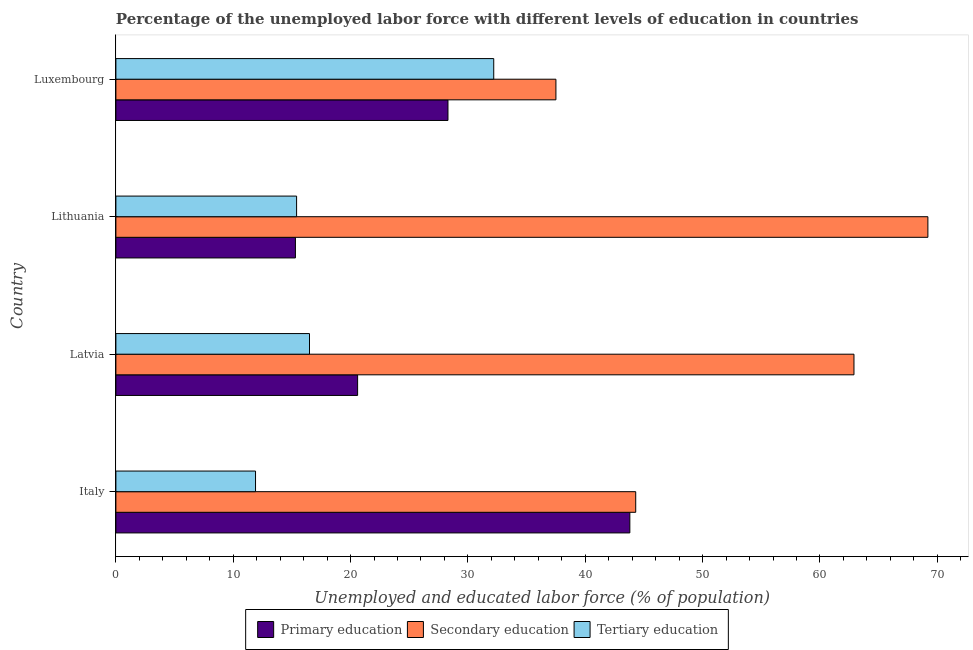How many different coloured bars are there?
Your answer should be very brief. 3. Are the number of bars on each tick of the Y-axis equal?
Your answer should be very brief. Yes. What is the label of the 2nd group of bars from the top?
Offer a very short reply. Lithuania. In how many cases, is the number of bars for a given country not equal to the number of legend labels?
Your answer should be compact. 0. What is the percentage of labor force who received primary education in Latvia?
Your answer should be very brief. 20.6. Across all countries, what is the maximum percentage of labor force who received primary education?
Your answer should be very brief. 43.8. Across all countries, what is the minimum percentage of labor force who received primary education?
Offer a very short reply. 15.3. In which country was the percentage of labor force who received tertiary education maximum?
Offer a very short reply. Luxembourg. What is the total percentage of labor force who received primary education in the graph?
Provide a succinct answer. 108. What is the difference between the percentage of labor force who received primary education in Luxembourg and the percentage of labor force who received tertiary education in Lithuania?
Provide a succinct answer. 12.9. What is the average percentage of labor force who received secondary education per country?
Your answer should be very brief. 53.48. What is the difference between the percentage of labor force who received secondary education and percentage of labor force who received tertiary education in Lithuania?
Provide a short and direct response. 53.8. What is the ratio of the percentage of labor force who received secondary education in Italy to that in Latvia?
Your response must be concise. 0.7. Is the percentage of labor force who received tertiary education in Italy less than that in Lithuania?
Your answer should be very brief. Yes. Is the difference between the percentage of labor force who received primary education in Italy and Luxembourg greater than the difference between the percentage of labor force who received secondary education in Italy and Luxembourg?
Provide a succinct answer. Yes. What is the difference between the highest and the lowest percentage of labor force who received primary education?
Make the answer very short. 28.5. What does the 2nd bar from the top in Latvia represents?
Offer a very short reply. Secondary education. What does the 1st bar from the bottom in Luxembourg represents?
Your answer should be compact. Primary education. How many bars are there?
Offer a very short reply. 12. Are all the bars in the graph horizontal?
Keep it short and to the point. Yes. How many countries are there in the graph?
Offer a very short reply. 4. Does the graph contain any zero values?
Your answer should be very brief. No. How are the legend labels stacked?
Provide a short and direct response. Horizontal. What is the title of the graph?
Provide a short and direct response. Percentage of the unemployed labor force with different levels of education in countries. What is the label or title of the X-axis?
Provide a short and direct response. Unemployed and educated labor force (% of population). What is the Unemployed and educated labor force (% of population) of Primary education in Italy?
Your answer should be compact. 43.8. What is the Unemployed and educated labor force (% of population) of Secondary education in Italy?
Keep it short and to the point. 44.3. What is the Unemployed and educated labor force (% of population) in Tertiary education in Italy?
Your answer should be very brief. 11.9. What is the Unemployed and educated labor force (% of population) in Primary education in Latvia?
Your response must be concise. 20.6. What is the Unemployed and educated labor force (% of population) in Secondary education in Latvia?
Your answer should be very brief. 62.9. What is the Unemployed and educated labor force (% of population) in Tertiary education in Latvia?
Offer a terse response. 16.5. What is the Unemployed and educated labor force (% of population) of Primary education in Lithuania?
Your response must be concise. 15.3. What is the Unemployed and educated labor force (% of population) of Secondary education in Lithuania?
Give a very brief answer. 69.2. What is the Unemployed and educated labor force (% of population) in Tertiary education in Lithuania?
Your answer should be very brief. 15.4. What is the Unemployed and educated labor force (% of population) in Primary education in Luxembourg?
Offer a terse response. 28.3. What is the Unemployed and educated labor force (% of population) in Secondary education in Luxembourg?
Your response must be concise. 37.5. What is the Unemployed and educated labor force (% of population) of Tertiary education in Luxembourg?
Offer a terse response. 32.2. Across all countries, what is the maximum Unemployed and educated labor force (% of population) in Primary education?
Keep it short and to the point. 43.8. Across all countries, what is the maximum Unemployed and educated labor force (% of population) in Secondary education?
Ensure brevity in your answer.  69.2. Across all countries, what is the maximum Unemployed and educated labor force (% of population) of Tertiary education?
Make the answer very short. 32.2. Across all countries, what is the minimum Unemployed and educated labor force (% of population) in Primary education?
Give a very brief answer. 15.3. Across all countries, what is the minimum Unemployed and educated labor force (% of population) of Secondary education?
Offer a very short reply. 37.5. Across all countries, what is the minimum Unemployed and educated labor force (% of population) in Tertiary education?
Provide a succinct answer. 11.9. What is the total Unemployed and educated labor force (% of population) of Primary education in the graph?
Your answer should be very brief. 108. What is the total Unemployed and educated labor force (% of population) of Secondary education in the graph?
Ensure brevity in your answer.  213.9. What is the difference between the Unemployed and educated labor force (% of population) of Primary education in Italy and that in Latvia?
Make the answer very short. 23.2. What is the difference between the Unemployed and educated labor force (% of population) in Secondary education in Italy and that in Latvia?
Provide a short and direct response. -18.6. What is the difference between the Unemployed and educated labor force (% of population) in Primary education in Italy and that in Lithuania?
Your answer should be compact. 28.5. What is the difference between the Unemployed and educated labor force (% of population) of Secondary education in Italy and that in Lithuania?
Provide a succinct answer. -24.9. What is the difference between the Unemployed and educated labor force (% of population) in Secondary education in Italy and that in Luxembourg?
Your answer should be compact. 6.8. What is the difference between the Unemployed and educated labor force (% of population) of Tertiary education in Italy and that in Luxembourg?
Provide a succinct answer. -20.3. What is the difference between the Unemployed and educated labor force (% of population) of Secondary education in Latvia and that in Lithuania?
Your response must be concise. -6.3. What is the difference between the Unemployed and educated labor force (% of population) in Primary education in Latvia and that in Luxembourg?
Offer a terse response. -7.7. What is the difference between the Unemployed and educated labor force (% of population) of Secondary education in Latvia and that in Luxembourg?
Offer a terse response. 25.4. What is the difference between the Unemployed and educated labor force (% of population) in Tertiary education in Latvia and that in Luxembourg?
Keep it short and to the point. -15.7. What is the difference between the Unemployed and educated labor force (% of population) of Primary education in Lithuania and that in Luxembourg?
Offer a very short reply. -13. What is the difference between the Unemployed and educated labor force (% of population) in Secondary education in Lithuania and that in Luxembourg?
Provide a short and direct response. 31.7. What is the difference between the Unemployed and educated labor force (% of population) of Tertiary education in Lithuania and that in Luxembourg?
Your answer should be very brief. -16.8. What is the difference between the Unemployed and educated labor force (% of population) of Primary education in Italy and the Unemployed and educated labor force (% of population) of Secondary education in Latvia?
Your answer should be compact. -19.1. What is the difference between the Unemployed and educated labor force (% of population) in Primary education in Italy and the Unemployed and educated labor force (% of population) in Tertiary education in Latvia?
Ensure brevity in your answer.  27.3. What is the difference between the Unemployed and educated labor force (% of population) in Secondary education in Italy and the Unemployed and educated labor force (% of population) in Tertiary education in Latvia?
Your answer should be very brief. 27.8. What is the difference between the Unemployed and educated labor force (% of population) of Primary education in Italy and the Unemployed and educated labor force (% of population) of Secondary education in Lithuania?
Your response must be concise. -25.4. What is the difference between the Unemployed and educated labor force (% of population) of Primary education in Italy and the Unemployed and educated labor force (% of population) of Tertiary education in Lithuania?
Ensure brevity in your answer.  28.4. What is the difference between the Unemployed and educated labor force (% of population) in Secondary education in Italy and the Unemployed and educated labor force (% of population) in Tertiary education in Lithuania?
Give a very brief answer. 28.9. What is the difference between the Unemployed and educated labor force (% of population) of Primary education in Italy and the Unemployed and educated labor force (% of population) of Secondary education in Luxembourg?
Offer a very short reply. 6.3. What is the difference between the Unemployed and educated labor force (% of population) of Primary education in Italy and the Unemployed and educated labor force (% of population) of Tertiary education in Luxembourg?
Offer a very short reply. 11.6. What is the difference between the Unemployed and educated labor force (% of population) in Primary education in Latvia and the Unemployed and educated labor force (% of population) in Secondary education in Lithuania?
Your response must be concise. -48.6. What is the difference between the Unemployed and educated labor force (% of population) in Secondary education in Latvia and the Unemployed and educated labor force (% of population) in Tertiary education in Lithuania?
Make the answer very short. 47.5. What is the difference between the Unemployed and educated labor force (% of population) in Primary education in Latvia and the Unemployed and educated labor force (% of population) in Secondary education in Luxembourg?
Offer a terse response. -16.9. What is the difference between the Unemployed and educated labor force (% of population) of Secondary education in Latvia and the Unemployed and educated labor force (% of population) of Tertiary education in Luxembourg?
Your response must be concise. 30.7. What is the difference between the Unemployed and educated labor force (% of population) of Primary education in Lithuania and the Unemployed and educated labor force (% of population) of Secondary education in Luxembourg?
Your answer should be compact. -22.2. What is the difference between the Unemployed and educated labor force (% of population) in Primary education in Lithuania and the Unemployed and educated labor force (% of population) in Tertiary education in Luxembourg?
Your answer should be compact. -16.9. What is the difference between the Unemployed and educated labor force (% of population) in Secondary education in Lithuania and the Unemployed and educated labor force (% of population) in Tertiary education in Luxembourg?
Keep it short and to the point. 37. What is the average Unemployed and educated labor force (% of population) of Secondary education per country?
Your answer should be compact. 53.48. What is the difference between the Unemployed and educated labor force (% of population) in Primary education and Unemployed and educated labor force (% of population) in Secondary education in Italy?
Make the answer very short. -0.5. What is the difference between the Unemployed and educated labor force (% of population) in Primary education and Unemployed and educated labor force (% of population) in Tertiary education in Italy?
Provide a short and direct response. 31.9. What is the difference between the Unemployed and educated labor force (% of population) in Secondary education and Unemployed and educated labor force (% of population) in Tertiary education in Italy?
Your answer should be very brief. 32.4. What is the difference between the Unemployed and educated labor force (% of population) of Primary education and Unemployed and educated labor force (% of population) of Secondary education in Latvia?
Ensure brevity in your answer.  -42.3. What is the difference between the Unemployed and educated labor force (% of population) in Primary education and Unemployed and educated labor force (% of population) in Tertiary education in Latvia?
Provide a short and direct response. 4.1. What is the difference between the Unemployed and educated labor force (% of population) in Secondary education and Unemployed and educated labor force (% of population) in Tertiary education in Latvia?
Your response must be concise. 46.4. What is the difference between the Unemployed and educated labor force (% of population) of Primary education and Unemployed and educated labor force (% of population) of Secondary education in Lithuania?
Your answer should be compact. -53.9. What is the difference between the Unemployed and educated labor force (% of population) in Primary education and Unemployed and educated labor force (% of population) in Tertiary education in Lithuania?
Provide a succinct answer. -0.1. What is the difference between the Unemployed and educated labor force (% of population) of Secondary education and Unemployed and educated labor force (% of population) of Tertiary education in Lithuania?
Give a very brief answer. 53.8. What is the difference between the Unemployed and educated labor force (% of population) in Primary education and Unemployed and educated labor force (% of population) in Secondary education in Luxembourg?
Offer a very short reply. -9.2. What is the difference between the Unemployed and educated labor force (% of population) in Primary education and Unemployed and educated labor force (% of population) in Tertiary education in Luxembourg?
Your response must be concise. -3.9. What is the ratio of the Unemployed and educated labor force (% of population) of Primary education in Italy to that in Latvia?
Keep it short and to the point. 2.13. What is the ratio of the Unemployed and educated labor force (% of population) in Secondary education in Italy to that in Latvia?
Make the answer very short. 0.7. What is the ratio of the Unemployed and educated labor force (% of population) in Tertiary education in Italy to that in Latvia?
Your answer should be compact. 0.72. What is the ratio of the Unemployed and educated labor force (% of population) of Primary education in Italy to that in Lithuania?
Your response must be concise. 2.86. What is the ratio of the Unemployed and educated labor force (% of population) of Secondary education in Italy to that in Lithuania?
Provide a short and direct response. 0.64. What is the ratio of the Unemployed and educated labor force (% of population) of Tertiary education in Italy to that in Lithuania?
Provide a short and direct response. 0.77. What is the ratio of the Unemployed and educated labor force (% of population) in Primary education in Italy to that in Luxembourg?
Offer a terse response. 1.55. What is the ratio of the Unemployed and educated labor force (% of population) of Secondary education in Italy to that in Luxembourg?
Your answer should be compact. 1.18. What is the ratio of the Unemployed and educated labor force (% of population) of Tertiary education in Italy to that in Luxembourg?
Keep it short and to the point. 0.37. What is the ratio of the Unemployed and educated labor force (% of population) of Primary education in Latvia to that in Lithuania?
Offer a very short reply. 1.35. What is the ratio of the Unemployed and educated labor force (% of population) in Secondary education in Latvia to that in Lithuania?
Your response must be concise. 0.91. What is the ratio of the Unemployed and educated labor force (% of population) in Tertiary education in Latvia to that in Lithuania?
Your answer should be compact. 1.07. What is the ratio of the Unemployed and educated labor force (% of population) of Primary education in Latvia to that in Luxembourg?
Provide a short and direct response. 0.73. What is the ratio of the Unemployed and educated labor force (% of population) in Secondary education in Latvia to that in Luxembourg?
Your response must be concise. 1.68. What is the ratio of the Unemployed and educated labor force (% of population) of Tertiary education in Latvia to that in Luxembourg?
Provide a succinct answer. 0.51. What is the ratio of the Unemployed and educated labor force (% of population) of Primary education in Lithuania to that in Luxembourg?
Provide a short and direct response. 0.54. What is the ratio of the Unemployed and educated labor force (% of population) of Secondary education in Lithuania to that in Luxembourg?
Your answer should be compact. 1.85. What is the ratio of the Unemployed and educated labor force (% of population) in Tertiary education in Lithuania to that in Luxembourg?
Make the answer very short. 0.48. What is the difference between the highest and the second highest Unemployed and educated labor force (% of population) of Primary education?
Provide a short and direct response. 15.5. What is the difference between the highest and the second highest Unemployed and educated labor force (% of population) of Secondary education?
Provide a succinct answer. 6.3. What is the difference between the highest and the second highest Unemployed and educated labor force (% of population) in Tertiary education?
Your answer should be very brief. 15.7. What is the difference between the highest and the lowest Unemployed and educated labor force (% of population) of Secondary education?
Make the answer very short. 31.7. What is the difference between the highest and the lowest Unemployed and educated labor force (% of population) of Tertiary education?
Provide a short and direct response. 20.3. 